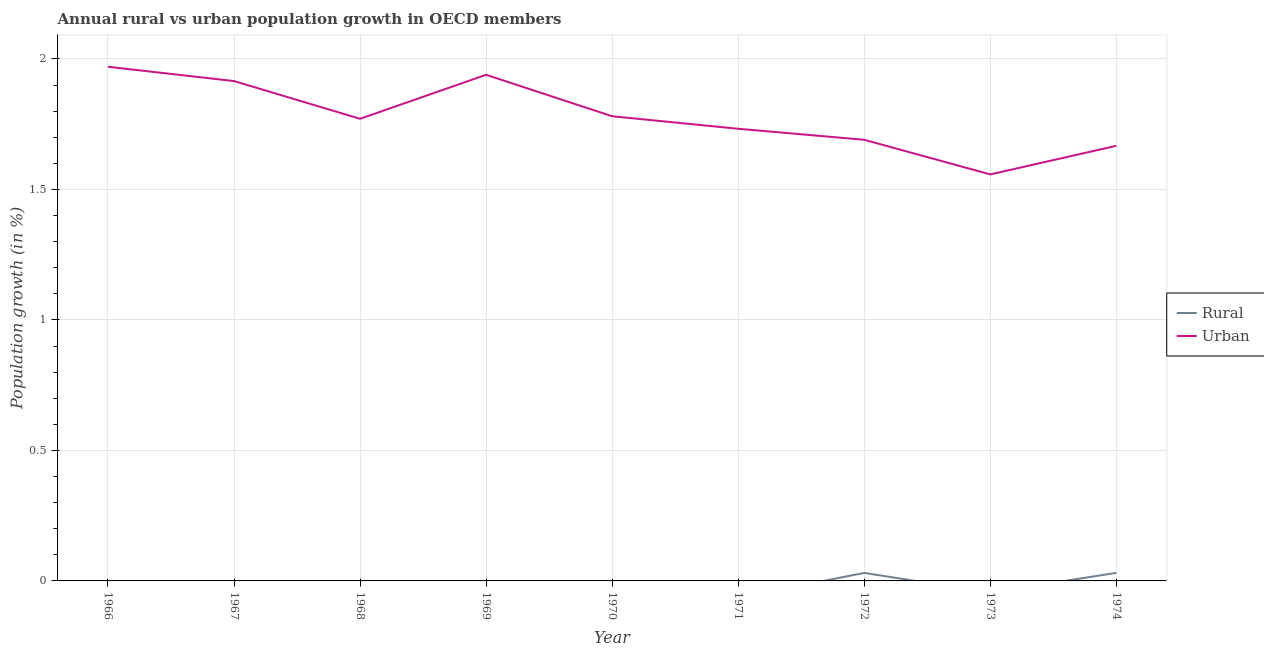How many different coloured lines are there?
Provide a short and direct response. 2. Does the line corresponding to urban population growth intersect with the line corresponding to rural population growth?
Give a very brief answer. No. What is the urban population growth in 1967?
Your answer should be compact. 1.92. Across all years, what is the maximum rural population growth?
Keep it short and to the point. 0.03. Across all years, what is the minimum rural population growth?
Keep it short and to the point. 0. In which year was the urban population growth maximum?
Your answer should be very brief. 1966. What is the total urban population growth in the graph?
Provide a short and direct response. 16.02. What is the difference between the urban population growth in 1967 and that in 1974?
Offer a terse response. 0.25. What is the difference between the urban population growth in 1971 and the rural population growth in 1972?
Make the answer very short. 1.7. What is the average urban population growth per year?
Your answer should be compact. 1.78. In the year 1974, what is the difference between the urban population growth and rural population growth?
Keep it short and to the point. 1.64. In how many years, is the rural population growth greater than 1.3 %?
Make the answer very short. 0. What is the ratio of the urban population growth in 1968 to that in 1971?
Make the answer very short. 1.02. Is the urban population growth in 1967 less than that in 1974?
Ensure brevity in your answer.  No. Is the difference between the urban population growth in 1972 and 1974 greater than the difference between the rural population growth in 1972 and 1974?
Provide a succinct answer. Yes. What is the difference between the highest and the second highest urban population growth?
Provide a succinct answer. 0.03. What is the difference between the highest and the lowest rural population growth?
Give a very brief answer. 0.03. In how many years, is the urban population growth greater than the average urban population growth taken over all years?
Keep it short and to the point. 4. Does the urban population growth monotonically increase over the years?
Your answer should be compact. No. Is the rural population growth strictly greater than the urban population growth over the years?
Make the answer very short. No. Is the urban population growth strictly less than the rural population growth over the years?
Offer a terse response. No. Are the values on the major ticks of Y-axis written in scientific E-notation?
Offer a terse response. No. Does the graph contain any zero values?
Ensure brevity in your answer.  Yes. Does the graph contain grids?
Offer a terse response. Yes. Where does the legend appear in the graph?
Give a very brief answer. Center right. What is the title of the graph?
Ensure brevity in your answer.  Annual rural vs urban population growth in OECD members. Does "Forest land" appear as one of the legend labels in the graph?
Provide a succinct answer. No. What is the label or title of the X-axis?
Provide a succinct answer. Year. What is the label or title of the Y-axis?
Your answer should be compact. Population growth (in %). What is the Population growth (in %) of Urban  in 1966?
Offer a very short reply. 1.97. What is the Population growth (in %) in Urban  in 1967?
Offer a very short reply. 1.92. What is the Population growth (in %) of Urban  in 1968?
Keep it short and to the point. 1.77. What is the Population growth (in %) in Urban  in 1969?
Your response must be concise. 1.94. What is the Population growth (in %) of Urban  in 1970?
Ensure brevity in your answer.  1.78. What is the Population growth (in %) in Urban  in 1971?
Provide a succinct answer. 1.73. What is the Population growth (in %) in Rural in 1972?
Give a very brief answer. 0.03. What is the Population growth (in %) in Urban  in 1972?
Provide a short and direct response. 1.69. What is the Population growth (in %) of Urban  in 1973?
Make the answer very short. 1.56. What is the Population growth (in %) in Rural in 1974?
Offer a terse response. 0.03. What is the Population growth (in %) of Urban  in 1974?
Keep it short and to the point. 1.67. Across all years, what is the maximum Population growth (in %) in Rural?
Keep it short and to the point. 0.03. Across all years, what is the maximum Population growth (in %) in Urban ?
Offer a terse response. 1.97. Across all years, what is the minimum Population growth (in %) of Rural?
Offer a very short reply. 0. Across all years, what is the minimum Population growth (in %) of Urban ?
Offer a terse response. 1.56. What is the total Population growth (in %) in Rural in the graph?
Ensure brevity in your answer.  0.06. What is the total Population growth (in %) in Urban  in the graph?
Your response must be concise. 16.02. What is the difference between the Population growth (in %) in Urban  in 1966 and that in 1967?
Ensure brevity in your answer.  0.05. What is the difference between the Population growth (in %) of Urban  in 1966 and that in 1968?
Keep it short and to the point. 0.2. What is the difference between the Population growth (in %) in Urban  in 1966 and that in 1969?
Provide a short and direct response. 0.03. What is the difference between the Population growth (in %) in Urban  in 1966 and that in 1970?
Keep it short and to the point. 0.19. What is the difference between the Population growth (in %) in Urban  in 1966 and that in 1971?
Offer a very short reply. 0.24. What is the difference between the Population growth (in %) in Urban  in 1966 and that in 1972?
Your answer should be very brief. 0.28. What is the difference between the Population growth (in %) of Urban  in 1966 and that in 1973?
Your answer should be very brief. 0.41. What is the difference between the Population growth (in %) in Urban  in 1966 and that in 1974?
Provide a short and direct response. 0.3. What is the difference between the Population growth (in %) of Urban  in 1967 and that in 1968?
Your answer should be compact. 0.14. What is the difference between the Population growth (in %) in Urban  in 1967 and that in 1969?
Give a very brief answer. -0.02. What is the difference between the Population growth (in %) of Urban  in 1967 and that in 1970?
Keep it short and to the point. 0.13. What is the difference between the Population growth (in %) in Urban  in 1967 and that in 1971?
Offer a terse response. 0.18. What is the difference between the Population growth (in %) in Urban  in 1967 and that in 1972?
Your answer should be compact. 0.23. What is the difference between the Population growth (in %) in Urban  in 1967 and that in 1973?
Give a very brief answer. 0.36. What is the difference between the Population growth (in %) of Urban  in 1967 and that in 1974?
Provide a succinct answer. 0.25. What is the difference between the Population growth (in %) of Urban  in 1968 and that in 1969?
Provide a succinct answer. -0.17. What is the difference between the Population growth (in %) of Urban  in 1968 and that in 1970?
Give a very brief answer. -0.01. What is the difference between the Population growth (in %) of Urban  in 1968 and that in 1971?
Your answer should be compact. 0.04. What is the difference between the Population growth (in %) of Urban  in 1968 and that in 1972?
Provide a succinct answer. 0.08. What is the difference between the Population growth (in %) of Urban  in 1968 and that in 1973?
Your answer should be compact. 0.21. What is the difference between the Population growth (in %) of Urban  in 1968 and that in 1974?
Your answer should be very brief. 0.1. What is the difference between the Population growth (in %) in Urban  in 1969 and that in 1970?
Give a very brief answer. 0.16. What is the difference between the Population growth (in %) in Urban  in 1969 and that in 1971?
Offer a terse response. 0.21. What is the difference between the Population growth (in %) of Urban  in 1969 and that in 1972?
Your answer should be compact. 0.25. What is the difference between the Population growth (in %) in Urban  in 1969 and that in 1973?
Ensure brevity in your answer.  0.38. What is the difference between the Population growth (in %) of Urban  in 1969 and that in 1974?
Offer a terse response. 0.27. What is the difference between the Population growth (in %) in Urban  in 1970 and that in 1971?
Offer a terse response. 0.05. What is the difference between the Population growth (in %) in Urban  in 1970 and that in 1972?
Give a very brief answer. 0.09. What is the difference between the Population growth (in %) of Urban  in 1970 and that in 1973?
Make the answer very short. 0.22. What is the difference between the Population growth (in %) in Urban  in 1970 and that in 1974?
Your answer should be compact. 0.11. What is the difference between the Population growth (in %) in Urban  in 1971 and that in 1972?
Keep it short and to the point. 0.04. What is the difference between the Population growth (in %) of Urban  in 1971 and that in 1973?
Give a very brief answer. 0.17. What is the difference between the Population growth (in %) of Urban  in 1971 and that in 1974?
Offer a very short reply. 0.07. What is the difference between the Population growth (in %) of Urban  in 1972 and that in 1973?
Provide a short and direct response. 0.13. What is the difference between the Population growth (in %) of Rural in 1972 and that in 1974?
Provide a succinct answer. -0. What is the difference between the Population growth (in %) of Urban  in 1972 and that in 1974?
Provide a short and direct response. 0.02. What is the difference between the Population growth (in %) in Urban  in 1973 and that in 1974?
Provide a succinct answer. -0.11. What is the difference between the Population growth (in %) in Rural in 1972 and the Population growth (in %) in Urban  in 1973?
Ensure brevity in your answer.  -1.53. What is the difference between the Population growth (in %) of Rural in 1972 and the Population growth (in %) of Urban  in 1974?
Give a very brief answer. -1.64. What is the average Population growth (in %) of Rural per year?
Make the answer very short. 0.01. What is the average Population growth (in %) in Urban  per year?
Provide a succinct answer. 1.78. In the year 1972, what is the difference between the Population growth (in %) of Rural and Population growth (in %) of Urban ?
Offer a very short reply. -1.66. In the year 1974, what is the difference between the Population growth (in %) in Rural and Population growth (in %) in Urban ?
Provide a succinct answer. -1.64. What is the ratio of the Population growth (in %) of Urban  in 1966 to that in 1967?
Give a very brief answer. 1.03. What is the ratio of the Population growth (in %) in Urban  in 1966 to that in 1968?
Provide a short and direct response. 1.11. What is the ratio of the Population growth (in %) in Urban  in 1966 to that in 1969?
Your answer should be compact. 1.02. What is the ratio of the Population growth (in %) in Urban  in 1966 to that in 1970?
Make the answer very short. 1.11. What is the ratio of the Population growth (in %) in Urban  in 1966 to that in 1971?
Keep it short and to the point. 1.14. What is the ratio of the Population growth (in %) in Urban  in 1966 to that in 1972?
Offer a very short reply. 1.17. What is the ratio of the Population growth (in %) of Urban  in 1966 to that in 1973?
Ensure brevity in your answer.  1.26. What is the ratio of the Population growth (in %) of Urban  in 1966 to that in 1974?
Provide a succinct answer. 1.18. What is the ratio of the Population growth (in %) in Urban  in 1967 to that in 1968?
Give a very brief answer. 1.08. What is the ratio of the Population growth (in %) in Urban  in 1967 to that in 1969?
Provide a succinct answer. 0.99. What is the ratio of the Population growth (in %) of Urban  in 1967 to that in 1970?
Your answer should be compact. 1.08. What is the ratio of the Population growth (in %) in Urban  in 1967 to that in 1971?
Your response must be concise. 1.11. What is the ratio of the Population growth (in %) of Urban  in 1967 to that in 1972?
Ensure brevity in your answer.  1.13. What is the ratio of the Population growth (in %) of Urban  in 1967 to that in 1973?
Your answer should be very brief. 1.23. What is the ratio of the Population growth (in %) of Urban  in 1967 to that in 1974?
Offer a very short reply. 1.15. What is the ratio of the Population growth (in %) of Urban  in 1968 to that in 1969?
Offer a very short reply. 0.91. What is the ratio of the Population growth (in %) in Urban  in 1968 to that in 1970?
Offer a very short reply. 0.99. What is the ratio of the Population growth (in %) of Urban  in 1968 to that in 1971?
Your response must be concise. 1.02. What is the ratio of the Population growth (in %) of Urban  in 1968 to that in 1972?
Offer a very short reply. 1.05. What is the ratio of the Population growth (in %) of Urban  in 1968 to that in 1973?
Ensure brevity in your answer.  1.14. What is the ratio of the Population growth (in %) in Urban  in 1968 to that in 1974?
Offer a terse response. 1.06. What is the ratio of the Population growth (in %) in Urban  in 1969 to that in 1970?
Provide a short and direct response. 1.09. What is the ratio of the Population growth (in %) in Urban  in 1969 to that in 1971?
Ensure brevity in your answer.  1.12. What is the ratio of the Population growth (in %) in Urban  in 1969 to that in 1972?
Ensure brevity in your answer.  1.15. What is the ratio of the Population growth (in %) of Urban  in 1969 to that in 1973?
Keep it short and to the point. 1.25. What is the ratio of the Population growth (in %) in Urban  in 1969 to that in 1974?
Provide a succinct answer. 1.16. What is the ratio of the Population growth (in %) in Urban  in 1970 to that in 1971?
Offer a terse response. 1.03. What is the ratio of the Population growth (in %) in Urban  in 1970 to that in 1972?
Offer a very short reply. 1.05. What is the ratio of the Population growth (in %) in Urban  in 1970 to that in 1973?
Your response must be concise. 1.14. What is the ratio of the Population growth (in %) of Urban  in 1970 to that in 1974?
Make the answer very short. 1.07. What is the ratio of the Population growth (in %) in Urban  in 1971 to that in 1972?
Keep it short and to the point. 1.02. What is the ratio of the Population growth (in %) in Urban  in 1971 to that in 1973?
Offer a terse response. 1.11. What is the ratio of the Population growth (in %) in Urban  in 1971 to that in 1974?
Make the answer very short. 1.04. What is the ratio of the Population growth (in %) of Urban  in 1972 to that in 1973?
Offer a terse response. 1.09. What is the ratio of the Population growth (in %) in Rural in 1972 to that in 1974?
Offer a very short reply. 0.99. What is the ratio of the Population growth (in %) in Urban  in 1972 to that in 1974?
Offer a very short reply. 1.01. What is the ratio of the Population growth (in %) in Urban  in 1973 to that in 1974?
Ensure brevity in your answer.  0.93. What is the difference between the highest and the second highest Population growth (in %) of Urban ?
Offer a very short reply. 0.03. What is the difference between the highest and the lowest Population growth (in %) of Rural?
Offer a terse response. 0.03. What is the difference between the highest and the lowest Population growth (in %) in Urban ?
Offer a very short reply. 0.41. 